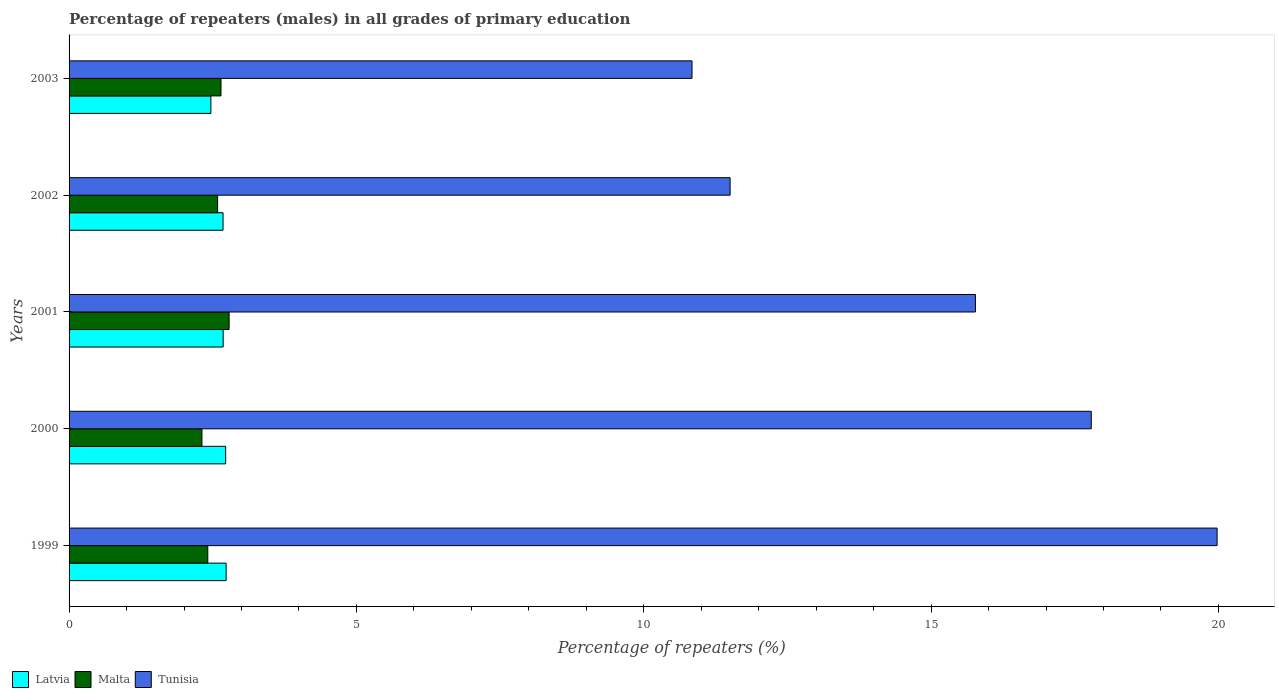How many different coloured bars are there?
Your answer should be compact. 3. How many bars are there on the 3rd tick from the bottom?
Your answer should be compact. 3. What is the label of the 1st group of bars from the top?
Provide a succinct answer. 2003. What is the percentage of repeaters (males) in Tunisia in 2001?
Give a very brief answer. 15.77. Across all years, what is the maximum percentage of repeaters (males) in Tunisia?
Make the answer very short. 19.98. Across all years, what is the minimum percentage of repeaters (males) in Tunisia?
Offer a terse response. 10.84. In which year was the percentage of repeaters (males) in Latvia minimum?
Make the answer very short. 2003. What is the total percentage of repeaters (males) in Latvia in the graph?
Keep it short and to the point. 13.29. What is the difference between the percentage of repeaters (males) in Tunisia in 1999 and that in 2000?
Make the answer very short. 2.19. What is the difference between the percentage of repeaters (males) in Latvia in 2000 and the percentage of repeaters (males) in Malta in 2001?
Provide a succinct answer. -0.06. What is the average percentage of repeaters (males) in Malta per year?
Provide a succinct answer. 2.55. In the year 1999, what is the difference between the percentage of repeaters (males) in Malta and percentage of repeaters (males) in Latvia?
Ensure brevity in your answer.  -0.32. In how many years, is the percentage of repeaters (males) in Tunisia greater than 11 %?
Provide a succinct answer. 4. What is the ratio of the percentage of repeaters (males) in Latvia in 1999 to that in 2003?
Provide a succinct answer. 1.11. Is the percentage of repeaters (males) in Tunisia in 1999 less than that in 2000?
Offer a terse response. No. Is the difference between the percentage of repeaters (males) in Malta in 1999 and 2000 greater than the difference between the percentage of repeaters (males) in Latvia in 1999 and 2000?
Your answer should be compact. Yes. What is the difference between the highest and the second highest percentage of repeaters (males) in Latvia?
Ensure brevity in your answer.  0.01. What is the difference between the highest and the lowest percentage of repeaters (males) in Tunisia?
Provide a succinct answer. 9.14. What does the 1st bar from the top in 1999 represents?
Your answer should be compact. Tunisia. What does the 3rd bar from the bottom in 2000 represents?
Your response must be concise. Tunisia. How many bars are there?
Offer a terse response. 15. Are all the bars in the graph horizontal?
Your answer should be very brief. Yes. How many years are there in the graph?
Give a very brief answer. 5. What is the difference between two consecutive major ticks on the X-axis?
Provide a succinct answer. 5. Does the graph contain grids?
Your answer should be very brief. No. How many legend labels are there?
Keep it short and to the point. 3. How are the legend labels stacked?
Offer a very short reply. Horizontal. What is the title of the graph?
Your answer should be compact. Percentage of repeaters (males) in all grades of primary education. What is the label or title of the X-axis?
Offer a terse response. Percentage of repeaters (%). What is the label or title of the Y-axis?
Ensure brevity in your answer.  Years. What is the Percentage of repeaters (%) in Latvia in 1999?
Ensure brevity in your answer.  2.73. What is the Percentage of repeaters (%) in Malta in 1999?
Provide a short and direct response. 2.41. What is the Percentage of repeaters (%) of Tunisia in 1999?
Give a very brief answer. 19.98. What is the Percentage of repeaters (%) in Latvia in 2000?
Provide a short and direct response. 2.72. What is the Percentage of repeaters (%) in Malta in 2000?
Your answer should be very brief. 2.31. What is the Percentage of repeaters (%) in Tunisia in 2000?
Give a very brief answer. 17.79. What is the Percentage of repeaters (%) of Latvia in 2001?
Offer a very short reply. 2.68. What is the Percentage of repeaters (%) of Malta in 2001?
Offer a very short reply. 2.78. What is the Percentage of repeaters (%) in Tunisia in 2001?
Your answer should be compact. 15.77. What is the Percentage of repeaters (%) of Latvia in 2002?
Offer a terse response. 2.68. What is the Percentage of repeaters (%) of Malta in 2002?
Give a very brief answer. 2.58. What is the Percentage of repeaters (%) in Tunisia in 2002?
Your answer should be very brief. 11.5. What is the Percentage of repeaters (%) of Latvia in 2003?
Your answer should be compact. 2.47. What is the Percentage of repeaters (%) in Malta in 2003?
Ensure brevity in your answer.  2.64. What is the Percentage of repeaters (%) of Tunisia in 2003?
Your answer should be compact. 10.84. Across all years, what is the maximum Percentage of repeaters (%) of Latvia?
Keep it short and to the point. 2.73. Across all years, what is the maximum Percentage of repeaters (%) in Malta?
Keep it short and to the point. 2.78. Across all years, what is the maximum Percentage of repeaters (%) of Tunisia?
Keep it short and to the point. 19.98. Across all years, what is the minimum Percentage of repeaters (%) of Latvia?
Your answer should be very brief. 2.47. Across all years, what is the minimum Percentage of repeaters (%) in Malta?
Keep it short and to the point. 2.31. Across all years, what is the minimum Percentage of repeaters (%) of Tunisia?
Offer a terse response. 10.84. What is the total Percentage of repeaters (%) of Latvia in the graph?
Provide a short and direct response. 13.29. What is the total Percentage of repeaters (%) in Malta in the graph?
Provide a succinct answer. 12.74. What is the total Percentage of repeaters (%) of Tunisia in the graph?
Ensure brevity in your answer.  75.88. What is the difference between the Percentage of repeaters (%) of Latvia in 1999 and that in 2000?
Offer a very short reply. 0.01. What is the difference between the Percentage of repeaters (%) in Malta in 1999 and that in 2000?
Your answer should be compact. 0.1. What is the difference between the Percentage of repeaters (%) of Tunisia in 1999 and that in 2000?
Your response must be concise. 2.19. What is the difference between the Percentage of repeaters (%) of Latvia in 1999 and that in 2001?
Offer a terse response. 0.05. What is the difference between the Percentage of repeaters (%) of Malta in 1999 and that in 2001?
Keep it short and to the point. -0.37. What is the difference between the Percentage of repeaters (%) of Tunisia in 1999 and that in 2001?
Keep it short and to the point. 4.21. What is the difference between the Percentage of repeaters (%) of Latvia in 1999 and that in 2002?
Make the answer very short. 0.05. What is the difference between the Percentage of repeaters (%) of Malta in 1999 and that in 2002?
Your answer should be compact. -0.17. What is the difference between the Percentage of repeaters (%) in Tunisia in 1999 and that in 2002?
Provide a short and direct response. 8.47. What is the difference between the Percentage of repeaters (%) in Latvia in 1999 and that in 2003?
Keep it short and to the point. 0.27. What is the difference between the Percentage of repeaters (%) in Malta in 1999 and that in 2003?
Make the answer very short. -0.23. What is the difference between the Percentage of repeaters (%) in Tunisia in 1999 and that in 2003?
Make the answer very short. 9.14. What is the difference between the Percentage of repeaters (%) in Latvia in 2000 and that in 2001?
Your response must be concise. 0.04. What is the difference between the Percentage of repeaters (%) in Malta in 2000 and that in 2001?
Provide a succinct answer. -0.47. What is the difference between the Percentage of repeaters (%) of Tunisia in 2000 and that in 2001?
Make the answer very short. 2.02. What is the difference between the Percentage of repeaters (%) in Latvia in 2000 and that in 2002?
Your response must be concise. 0.05. What is the difference between the Percentage of repeaters (%) in Malta in 2000 and that in 2002?
Your answer should be compact. -0.27. What is the difference between the Percentage of repeaters (%) of Tunisia in 2000 and that in 2002?
Offer a very short reply. 6.28. What is the difference between the Percentage of repeaters (%) in Latvia in 2000 and that in 2003?
Provide a succinct answer. 0.26. What is the difference between the Percentage of repeaters (%) in Malta in 2000 and that in 2003?
Ensure brevity in your answer.  -0.33. What is the difference between the Percentage of repeaters (%) in Tunisia in 2000 and that in 2003?
Make the answer very short. 6.95. What is the difference between the Percentage of repeaters (%) in Latvia in 2001 and that in 2002?
Offer a terse response. 0. What is the difference between the Percentage of repeaters (%) of Malta in 2001 and that in 2002?
Ensure brevity in your answer.  0.2. What is the difference between the Percentage of repeaters (%) of Tunisia in 2001 and that in 2002?
Provide a succinct answer. 4.27. What is the difference between the Percentage of repeaters (%) in Latvia in 2001 and that in 2003?
Your answer should be compact. 0.21. What is the difference between the Percentage of repeaters (%) in Malta in 2001 and that in 2003?
Offer a terse response. 0.14. What is the difference between the Percentage of repeaters (%) of Tunisia in 2001 and that in 2003?
Ensure brevity in your answer.  4.93. What is the difference between the Percentage of repeaters (%) in Latvia in 2002 and that in 2003?
Your answer should be compact. 0.21. What is the difference between the Percentage of repeaters (%) of Malta in 2002 and that in 2003?
Offer a terse response. -0.06. What is the difference between the Percentage of repeaters (%) of Tunisia in 2002 and that in 2003?
Ensure brevity in your answer.  0.66. What is the difference between the Percentage of repeaters (%) of Latvia in 1999 and the Percentage of repeaters (%) of Malta in 2000?
Give a very brief answer. 0.42. What is the difference between the Percentage of repeaters (%) in Latvia in 1999 and the Percentage of repeaters (%) in Tunisia in 2000?
Your answer should be compact. -15.05. What is the difference between the Percentage of repeaters (%) of Malta in 1999 and the Percentage of repeaters (%) of Tunisia in 2000?
Offer a very short reply. -15.37. What is the difference between the Percentage of repeaters (%) of Latvia in 1999 and the Percentage of repeaters (%) of Malta in 2001?
Your response must be concise. -0.05. What is the difference between the Percentage of repeaters (%) of Latvia in 1999 and the Percentage of repeaters (%) of Tunisia in 2001?
Give a very brief answer. -13.04. What is the difference between the Percentage of repeaters (%) in Malta in 1999 and the Percentage of repeaters (%) in Tunisia in 2001?
Provide a succinct answer. -13.36. What is the difference between the Percentage of repeaters (%) of Latvia in 1999 and the Percentage of repeaters (%) of Malta in 2002?
Keep it short and to the point. 0.15. What is the difference between the Percentage of repeaters (%) of Latvia in 1999 and the Percentage of repeaters (%) of Tunisia in 2002?
Give a very brief answer. -8.77. What is the difference between the Percentage of repeaters (%) in Malta in 1999 and the Percentage of repeaters (%) in Tunisia in 2002?
Ensure brevity in your answer.  -9.09. What is the difference between the Percentage of repeaters (%) of Latvia in 1999 and the Percentage of repeaters (%) of Malta in 2003?
Offer a terse response. 0.09. What is the difference between the Percentage of repeaters (%) in Latvia in 1999 and the Percentage of repeaters (%) in Tunisia in 2003?
Offer a terse response. -8.11. What is the difference between the Percentage of repeaters (%) in Malta in 1999 and the Percentage of repeaters (%) in Tunisia in 2003?
Make the answer very short. -8.43. What is the difference between the Percentage of repeaters (%) in Latvia in 2000 and the Percentage of repeaters (%) in Malta in 2001?
Offer a very short reply. -0.06. What is the difference between the Percentage of repeaters (%) in Latvia in 2000 and the Percentage of repeaters (%) in Tunisia in 2001?
Give a very brief answer. -13.05. What is the difference between the Percentage of repeaters (%) in Malta in 2000 and the Percentage of repeaters (%) in Tunisia in 2001?
Offer a very short reply. -13.46. What is the difference between the Percentage of repeaters (%) in Latvia in 2000 and the Percentage of repeaters (%) in Malta in 2002?
Make the answer very short. 0.14. What is the difference between the Percentage of repeaters (%) of Latvia in 2000 and the Percentage of repeaters (%) of Tunisia in 2002?
Make the answer very short. -8.78. What is the difference between the Percentage of repeaters (%) in Malta in 2000 and the Percentage of repeaters (%) in Tunisia in 2002?
Your response must be concise. -9.19. What is the difference between the Percentage of repeaters (%) in Latvia in 2000 and the Percentage of repeaters (%) in Malta in 2003?
Your answer should be compact. 0.08. What is the difference between the Percentage of repeaters (%) in Latvia in 2000 and the Percentage of repeaters (%) in Tunisia in 2003?
Your answer should be compact. -8.12. What is the difference between the Percentage of repeaters (%) of Malta in 2000 and the Percentage of repeaters (%) of Tunisia in 2003?
Provide a succinct answer. -8.53. What is the difference between the Percentage of repeaters (%) in Latvia in 2001 and the Percentage of repeaters (%) in Malta in 2002?
Make the answer very short. 0.1. What is the difference between the Percentage of repeaters (%) in Latvia in 2001 and the Percentage of repeaters (%) in Tunisia in 2002?
Offer a very short reply. -8.82. What is the difference between the Percentage of repeaters (%) of Malta in 2001 and the Percentage of repeaters (%) of Tunisia in 2002?
Your answer should be compact. -8.72. What is the difference between the Percentage of repeaters (%) of Latvia in 2001 and the Percentage of repeaters (%) of Malta in 2003?
Your answer should be compact. 0.04. What is the difference between the Percentage of repeaters (%) of Latvia in 2001 and the Percentage of repeaters (%) of Tunisia in 2003?
Your answer should be compact. -8.16. What is the difference between the Percentage of repeaters (%) of Malta in 2001 and the Percentage of repeaters (%) of Tunisia in 2003?
Provide a succinct answer. -8.05. What is the difference between the Percentage of repeaters (%) in Latvia in 2002 and the Percentage of repeaters (%) in Malta in 2003?
Make the answer very short. 0.04. What is the difference between the Percentage of repeaters (%) of Latvia in 2002 and the Percentage of repeaters (%) of Tunisia in 2003?
Offer a very short reply. -8.16. What is the difference between the Percentage of repeaters (%) of Malta in 2002 and the Percentage of repeaters (%) of Tunisia in 2003?
Provide a succinct answer. -8.26. What is the average Percentage of repeaters (%) in Latvia per year?
Your answer should be compact. 2.66. What is the average Percentage of repeaters (%) in Malta per year?
Offer a terse response. 2.55. What is the average Percentage of repeaters (%) of Tunisia per year?
Provide a short and direct response. 15.18. In the year 1999, what is the difference between the Percentage of repeaters (%) of Latvia and Percentage of repeaters (%) of Malta?
Offer a terse response. 0.32. In the year 1999, what is the difference between the Percentage of repeaters (%) of Latvia and Percentage of repeaters (%) of Tunisia?
Provide a succinct answer. -17.24. In the year 1999, what is the difference between the Percentage of repeaters (%) in Malta and Percentage of repeaters (%) in Tunisia?
Ensure brevity in your answer.  -17.56. In the year 2000, what is the difference between the Percentage of repeaters (%) in Latvia and Percentage of repeaters (%) in Malta?
Provide a succinct answer. 0.41. In the year 2000, what is the difference between the Percentage of repeaters (%) of Latvia and Percentage of repeaters (%) of Tunisia?
Provide a succinct answer. -15.06. In the year 2000, what is the difference between the Percentage of repeaters (%) of Malta and Percentage of repeaters (%) of Tunisia?
Keep it short and to the point. -15.48. In the year 2001, what is the difference between the Percentage of repeaters (%) of Latvia and Percentage of repeaters (%) of Malta?
Provide a succinct answer. -0.1. In the year 2001, what is the difference between the Percentage of repeaters (%) in Latvia and Percentage of repeaters (%) in Tunisia?
Offer a terse response. -13.09. In the year 2001, what is the difference between the Percentage of repeaters (%) of Malta and Percentage of repeaters (%) of Tunisia?
Offer a terse response. -12.99. In the year 2002, what is the difference between the Percentage of repeaters (%) in Latvia and Percentage of repeaters (%) in Malta?
Provide a short and direct response. 0.09. In the year 2002, what is the difference between the Percentage of repeaters (%) of Latvia and Percentage of repeaters (%) of Tunisia?
Keep it short and to the point. -8.82. In the year 2002, what is the difference between the Percentage of repeaters (%) in Malta and Percentage of repeaters (%) in Tunisia?
Ensure brevity in your answer.  -8.92. In the year 2003, what is the difference between the Percentage of repeaters (%) of Latvia and Percentage of repeaters (%) of Malta?
Make the answer very short. -0.18. In the year 2003, what is the difference between the Percentage of repeaters (%) in Latvia and Percentage of repeaters (%) in Tunisia?
Keep it short and to the point. -8.37. In the year 2003, what is the difference between the Percentage of repeaters (%) in Malta and Percentage of repeaters (%) in Tunisia?
Ensure brevity in your answer.  -8.2. What is the ratio of the Percentage of repeaters (%) in Malta in 1999 to that in 2000?
Keep it short and to the point. 1.04. What is the ratio of the Percentage of repeaters (%) in Tunisia in 1999 to that in 2000?
Your answer should be compact. 1.12. What is the ratio of the Percentage of repeaters (%) in Latvia in 1999 to that in 2001?
Give a very brief answer. 1.02. What is the ratio of the Percentage of repeaters (%) of Malta in 1999 to that in 2001?
Make the answer very short. 0.87. What is the ratio of the Percentage of repeaters (%) in Tunisia in 1999 to that in 2001?
Give a very brief answer. 1.27. What is the ratio of the Percentage of repeaters (%) in Latvia in 1999 to that in 2002?
Keep it short and to the point. 1.02. What is the ratio of the Percentage of repeaters (%) of Malta in 1999 to that in 2002?
Offer a terse response. 0.93. What is the ratio of the Percentage of repeaters (%) in Tunisia in 1999 to that in 2002?
Offer a terse response. 1.74. What is the ratio of the Percentage of repeaters (%) in Latvia in 1999 to that in 2003?
Keep it short and to the point. 1.11. What is the ratio of the Percentage of repeaters (%) in Malta in 1999 to that in 2003?
Make the answer very short. 0.91. What is the ratio of the Percentage of repeaters (%) in Tunisia in 1999 to that in 2003?
Your response must be concise. 1.84. What is the ratio of the Percentage of repeaters (%) in Latvia in 2000 to that in 2001?
Provide a short and direct response. 1.02. What is the ratio of the Percentage of repeaters (%) of Malta in 2000 to that in 2001?
Your response must be concise. 0.83. What is the ratio of the Percentage of repeaters (%) of Tunisia in 2000 to that in 2001?
Offer a very short reply. 1.13. What is the ratio of the Percentage of repeaters (%) in Latvia in 2000 to that in 2002?
Your answer should be very brief. 1.02. What is the ratio of the Percentage of repeaters (%) of Malta in 2000 to that in 2002?
Provide a succinct answer. 0.89. What is the ratio of the Percentage of repeaters (%) in Tunisia in 2000 to that in 2002?
Give a very brief answer. 1.55. What is the ratio of the Percentage of repeaters (%) of Latvia in 2000 to that in 2003?
Your answer should be compact. 1.1. What is the ratio of the Percentage of repeaters (%) of Malta in 2000 to that in 2003?
Offer a terse response. 0.87. What is the ratio of the Percentage of repeaters (%) of Tunisia in 2000 to that in 2003?
Provide a succinct answer. 1.64. What is the ratio of the Percentage of repeaters (%) in Latvia in 2001 to that in 2002?
Give a very brief answer. 1. What is the ratio of the Percentage of repeaters (%) in Malta in 2001 to that in 2002?
Offer a terse response. 1.08. What is the ratio of the Percentage of repeaters (%) in Tunisia in 2001 to that in 2002?
Provide a succinct answer. 1.37. What is the ratio of the Percentage of repeaters (%) in Latvia in 2001 to that in 2003?
Offer a terse response. 1.09. What is the ratio of the Percentage of repeaters (%) in Malta in 2001 to that in 2003?
Give a very brief answer. 1.05. What is the ratio of the Percentage of repeaters (%) in Tunisia in 2001 to that in 2003?
Your answer should be compact. 1.45. What is the ratio of the Percentage of repeaters (%) of Latvia in 2002 to that in 2003?
Provide a short and direct response. 1.09. What is the ratio of the Percentage of repeaters (%) of Malta in 2002 to that in 2003?
Keep it short and to the point. 0.98. What is the ratio of the Percentage of repeaters (%) of Tunisia in 2002 to that in 2003?
Give a very brief answer. 1.06. What is the difference between the highest and the second highest Percentage of repeaters (%) of Latvia?
Keep it short and to the point. 0.01. What is the difference between the highest and the second highest Percentage of repeaters (%) in Malta?
Provide a succinct answer. 0.14. What is the difference between the highest and the second highest Percentage of repeaters (%) in Tunisia?
Your answer should be very brief. 2.19. What is the difference between the highest and the lowest Percentage of repeaters (%) in Latvia?
Offer a terse response. 0.27. What is the difference between the highest and the lowest Percentage of repeaters (%) of Malta?
Provide a succinct answer. 0.47. What is the difference between the highest and the lowest Percentage of repeaters (%) in Tunisia?
Provide a succinct answer. 9.14. 